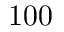<formula> <loc_0><loc_0><loc_500><loc_500>1 0 0</formula> 